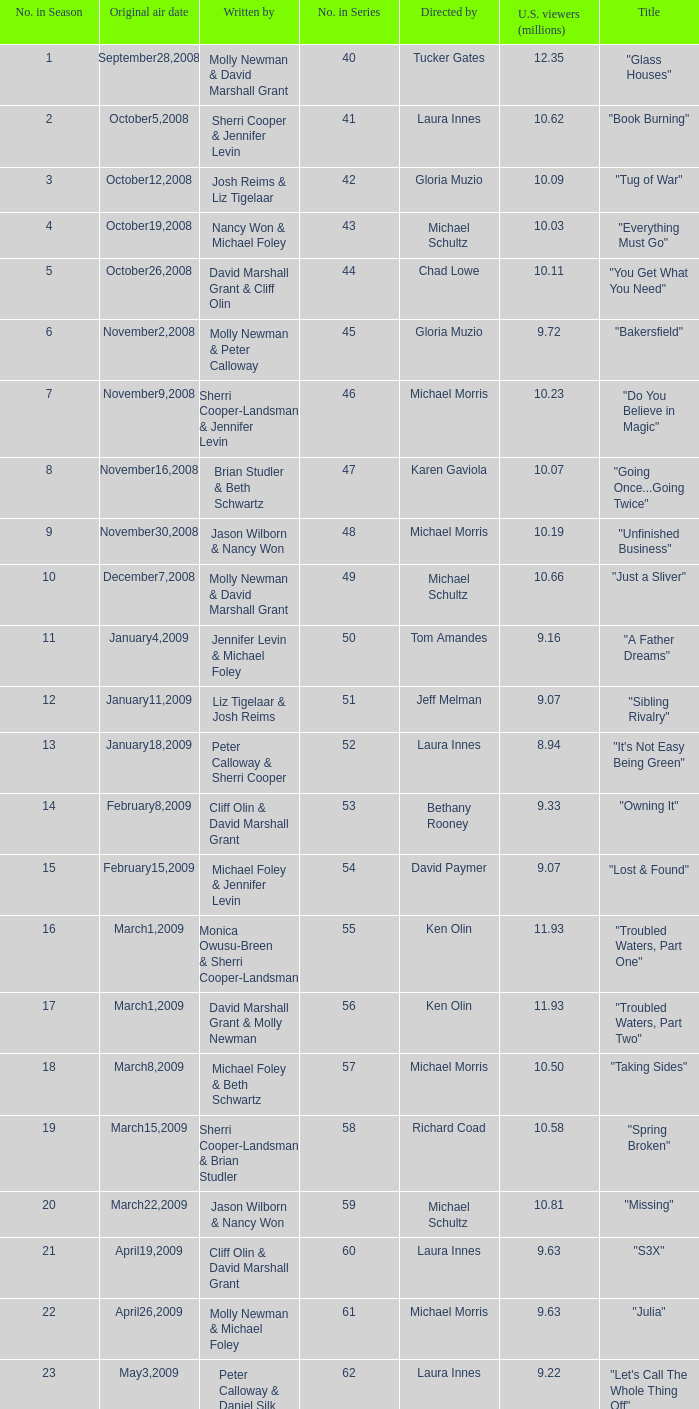Who wrote the episode whose director is Karen Gaviola? Brian Studler & Beth Schwartz. 